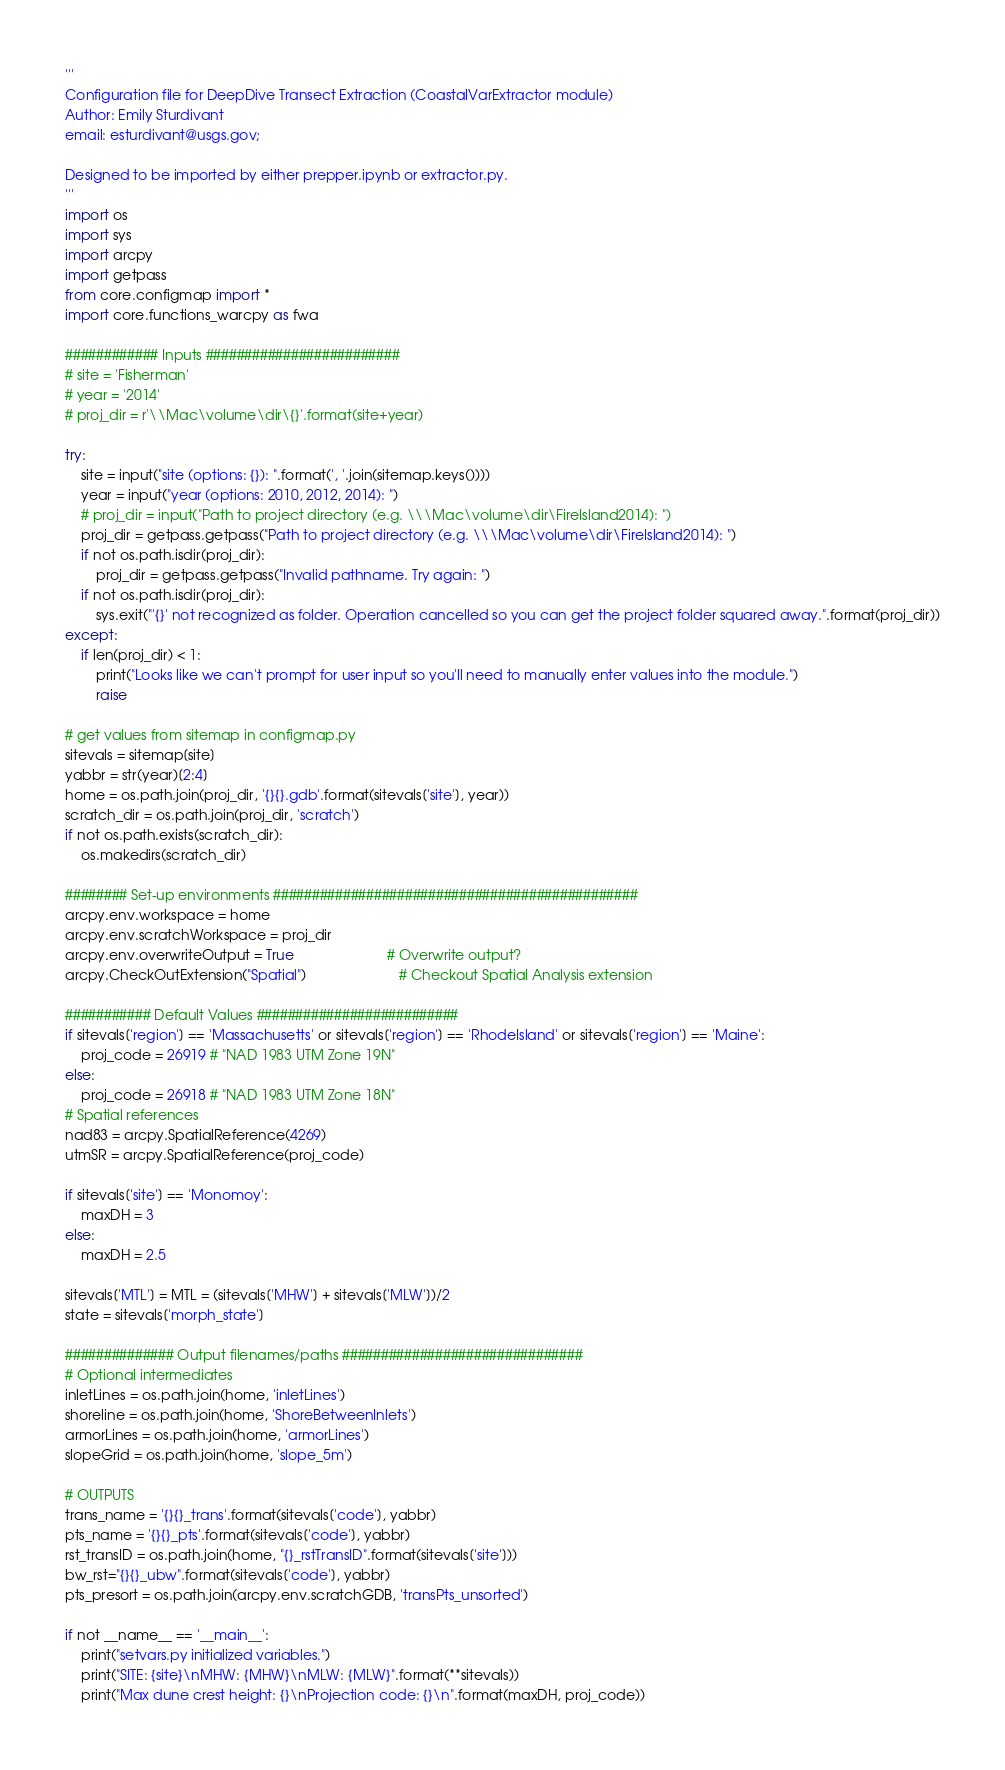<code> <loc_0><loc_0><loc_500><loc_500><_Python_>'''
Configuration file for DeepDive Transect Extraction (CoastalVarExtractor module)
Author: Emily Sturdivant
email: esturdivant@usgs.gov;

Designed to be imported by either prepper.ipynb or extractor.py.
'''
import os
import sys
import arcpy
import getpass
from core.configmap import *
import core.functions_warcpy as fwa

############ Inputs #########################
# site = 'Fisherman'
# year = '2014'
# proj_dir = r'\\Mac\volume\dir\{}'.format(site+year)

try:
    site = input("site (options: {}): ".format(', '.join(sitemap.keys())))
    year = input("year (options: 2010, 2012, 2014): ")
    # proj_dir = input("Path to project directory (e.g. \\\Mac\volume\dir\FireIsland2014): ")
    proj_dir = getpass.getpass("Path to project directory (e.g. \\\Mac\volume\dir\FireIsland2014): ")
    if not os.path.isdir(proj_dir):
        proj_dir = getpass.getpass("Invalid pathname. Try again: ")
    if not os.path.isdir(proj_dir):
        sys.exit("'{}' not recognized as folder. Operation cancelled so you can get the project folder squared away.".format(proj_dir))
except:
    if len(proj_dir) < 1:
        print("Looks like we can't prompt for user input so you'll need to manually enter values into the module.")
        raise

# get values from sitemap in configmap.py
sitevals = sitemap[site]
yabbr = str(year)[2:4]
home = os.path.join(proj_dir, '{}{}.gdb'.format(sitevals['site'], year))
scratch_dir = os.path.join(proj_dir, 'scratch')
if not os.path.exists(scratch_dir):
    os.makedirs(scratch_dir)

######## Set-up environments ###############################################
arcpy.env.workspace = home
arcpy.env.scratchWorkspace = proj_dir
arcpy.env.overwriteOutput = True 						# Overwrite output?
arcpy.CheckOutExtension("Spatial") 						# Checkout Spatial Analysis extension

########### Default Values ##########################
if sitevals['region'] == 'Massachusetts' or sitevals['region'] == 'RhodeIsland' or sitevals['region'] == 'Maine':
    proj_code = 26919 # "NAD 1983 UTM Zone 19N"
else:
    proj_code = 26918 # "NAD 1983 UTM Zone 18N"
# Spatial references
nad83 = arcpy.SpatialReference(4269)
utmSR = arcpy.SpatialReference(proj_code)

if sitevals['site'] == 'Monomoy':
    maxDH = 3
else:
    maxDH = 2.5

sitevals['MTL'] = MTL = (sitevals['MHW'] + sitevals['MLW'])/2
state = sitevals['morph_state']

############## Output filenames/paths ###############################
# Optional intermediates
inletLines = os.path.join(home, 'inletLines')
shoreline = os.path.join(home, 'ShoreBetweenInlets')
armorLines = os.path.join(home, 'armorLines')
slopeGrid = os.path.join(home, 'slope_5m')

# OUTPUTS
trans_name = '{}{}_trans'.format(sitevals['code'], yabbr)
pts_name = '{}{}_pts'.format(sitevals['code'], yabbr)
rst_transID = os.path.join(home, "{}_rstTransID".format(sitevals['site']))
bw_rst="{}{}_ubw".format(sitevals['code'], yabbr)
pts_presort = os.path.join(arcpy.env.scratchGDB, 'transPts_unsorted')

if not __name__ == '__main__':
    print("setvars.py initialized variables.")
    print("SITE: {site}\nMHW: {MHW}\nMLW: {MLW}".format(**sitevals))
    print("Max dune crest height: {}\nProjection code: {}\n".format(maxDH, proj_code))
</code> 